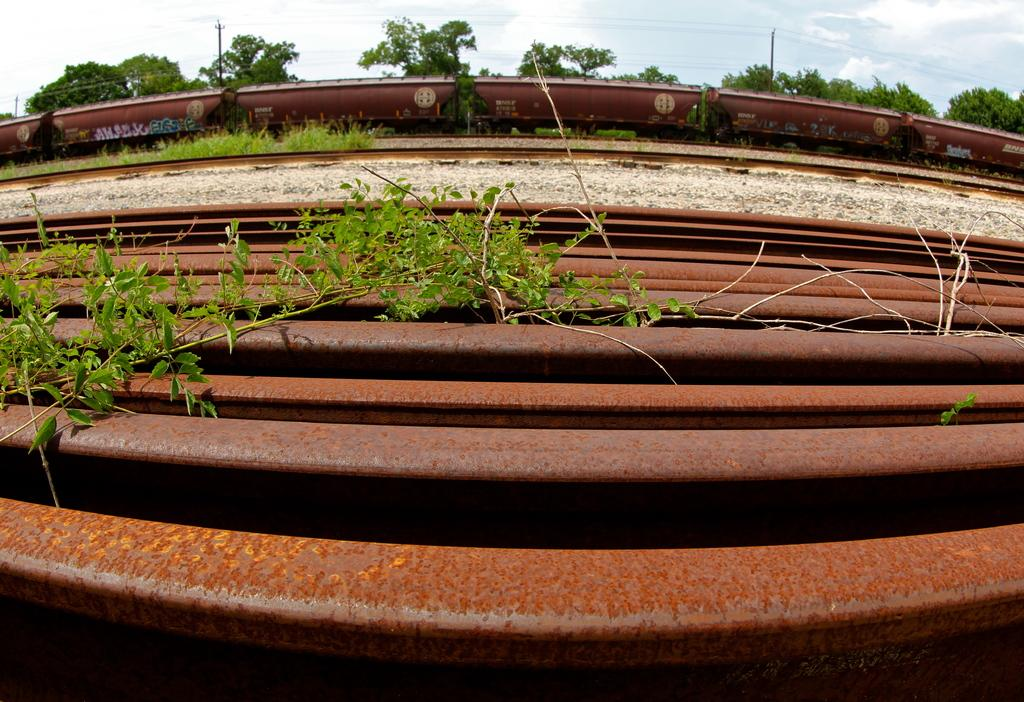What type of objects can be seen in the image? There are iron rods in the image. What is on the ground in the image? There are railway tracks on the ground in the image. What is moving along the railway tracks? There is a train visible in the image. What can be seen in the background of the image? There are trees at the back of the image. How many fans are visible in the image? There are no fans present in the image. What type of connection can be seen between the iron rods and the trees? There is no connection between the iron rods and the trees visible in the image. 